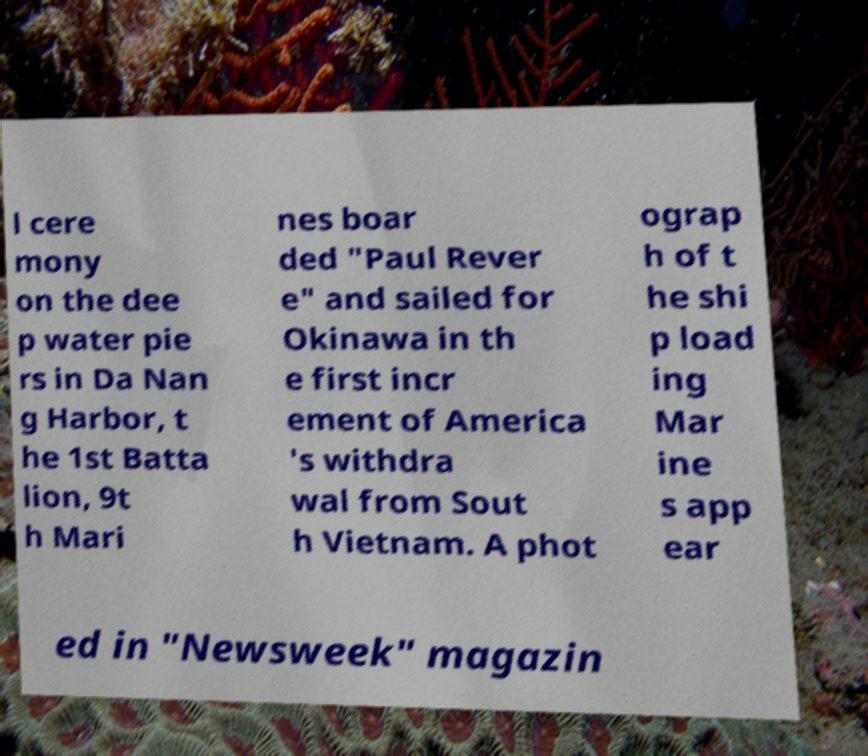There's text embedded in this image that I need extracted. Can you transcribe it verbatim? l cere mony on the dee p water pie rs in Da Nan g Harbor, t he 1st Batta lion, 9t h Mari nes boar ded "Paul Rever e" and sailed for Okinawa in th e first incr ement of America 's withdra wal from Sout h Vietnam. A phot ograp h of t he shi p load ing Mar ine s app ear ed in "Newsweek" magazin 